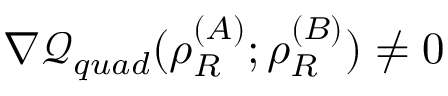Convert formula to latex. <formula><loc_0><loc_0><loc_500><loc_500>\nabla \mathcal { Q } _ { q u a d } ( \rho _ { R } ^ { ( A ) } ; \rho _ { R } ^ { ( B ) } ) \ne 0</formula> 